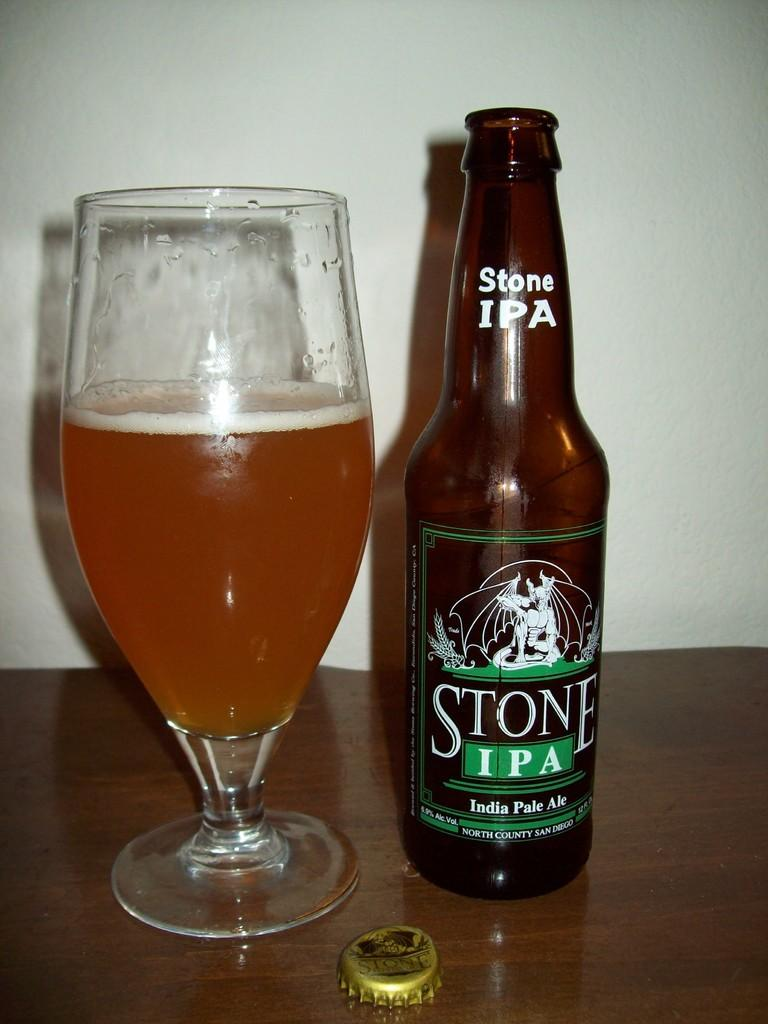<image>
Offer a succinct explanation of the picture presented. A bottle of Stone IPA next to a half full glass. 